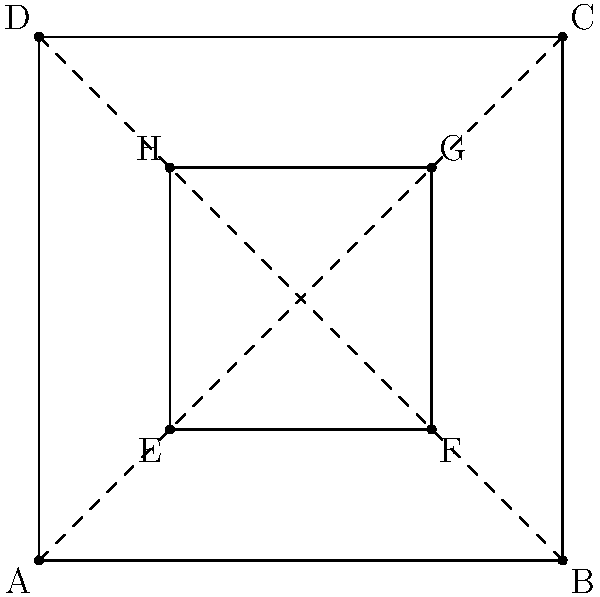In this geometric representation of a 19th-century bookplate design, two squares are depicted: an outer square ABCD and an inner square EFGH. The diagonals of the outer square are shown as dashed lines. If the area of the outer square is 16 square units, what is the area of the inner square? Let's approach this step-by-step:

1) First, we need to understand the relationship between the outer and inner squares. The inner square appears to be formed by connecting the midpoints of the sides of the outer square.

2) Given that the area of the outer square is 16 square units, we can find its side length:
   $$ A = s^2 $$
   $$ 16 = s^2 $$
   $$ s = 4 $$
   So, the side length of the outer square is 4 units.

3) Now, let's consider one side of the inner square. It connects the midpoints of two adjacent sides of the outer square.

4) In a square, the line segment connecting the midpoints of two adjacent sides forms a right triangle with these sides. This triangle is similar to the larger triangle formed by the diagonal of the square.

5) The hypotenuse of this smaller right triangle is a side of the inner square. We can find its length using the Pythagorean theorem:
   $$ (\frac{1}{2}s)^2 + (\frac{1}{2}s)^2 = (\text{inner side})^2 $$
   $$ 2(\frac{1}{2}s)^2 = (\text{inner side})^2 $$
   $$ 2(\frac{1}{2} \cdot 4)^2 = (\text{inner side})^2 $$
   $$ 2(2)^2 = (\text{inner side})^2 $$
   $$ 8 = (\text{inner side})^2 $$
   $$ \text{inner side} = 2\sqrt{2} $$

6) Now that we have the side length of the inner square, we can calculate its area:
   $$ A_{inner} = (2\sqrt{2})^2 = 8 $$

Therefore, the area of the inner square is 8 square units.
Answer: 8 square units 